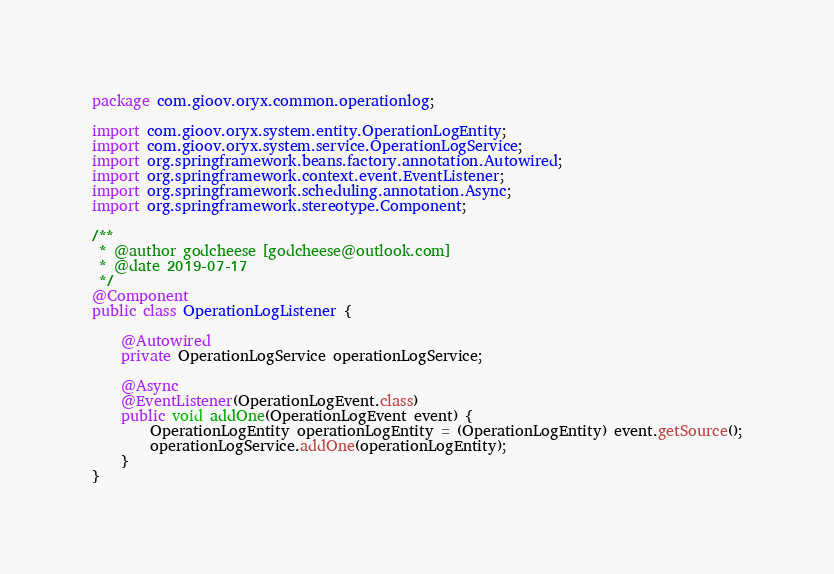<code> <loc_0><loc_0><loc_500><loc_500><_Java_>package com.gioov.oryx.common.operationlog;

import com.gioov.oryx.system.entity.OperationLogEntity;
import com.gioov.oryx.system.service.OperationLogService;
import org.springframework.beans.factory.annotation.Autowired;
import org.springframework.context.event.EventListener;
import org.springframework.scheduling.annotation.Async;
import org.springframework.stereotype.Component;

/**
 * @author godcheese [godcheese@outlook.com]
 * @date 2019-07-17
 */
@Component
public class OperationLogListener {

    @Autowired
    private OperationLogService operationLogService;

    @Async
    @EventListener(OperationLogEvent.class)
    public void addOne(OperationLogEvent event) {
        OperationLogEntity operationLogEntity = (OperationLogEntity) event.getSource();
        operationLogService.addOne(operationLogEntity);
    }
}
</code> 